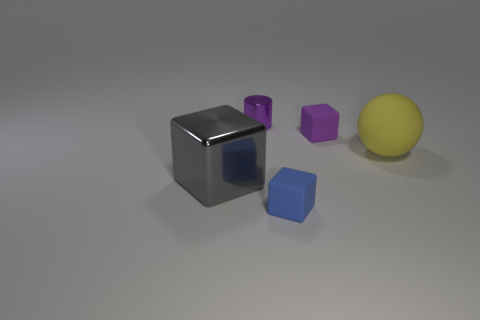The purple metallic cylinder is what size?
Offer a terse response. Small. Does the small shiny object have the same color as the tiny rubber thing behind the yellow thing?
Offer a terse response. Yes. What number of other objects are the same color as the big metallic block?
Make the answer very short. 0. Is the size of the block on the left side of the small blue rubber object the same as the cube behind the big gray object?
Provide a succinct answer. No. The large object left of the metal cylinder is what color?
Your answer should be compact. Gray. Are there fewer balls that are in front of the blue matte cube than shiny objects?
Make the answer very short. Yes. Are the yellow thing and the purple cylinder made of the same material?
Your answer should be very brief. No. What is the size of the blue thing that is the same shape as the gray shiny thing?
Keep it short and to the point. Small. How many objects are either small things behind the blue matte object or cubes in front of the large yellow rubber thing?
Ensure brevity in your answer.  4. Is the number of small purple blocks less than the number of tiny brown cubes?
Give a very brief answer. No. 